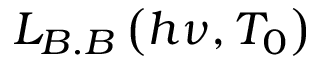<formula> <loc_0><loc_0><loc_500><loc_500>L _ { B . B } \left ( h \nu , T _ { 0 } \right )</formula> 